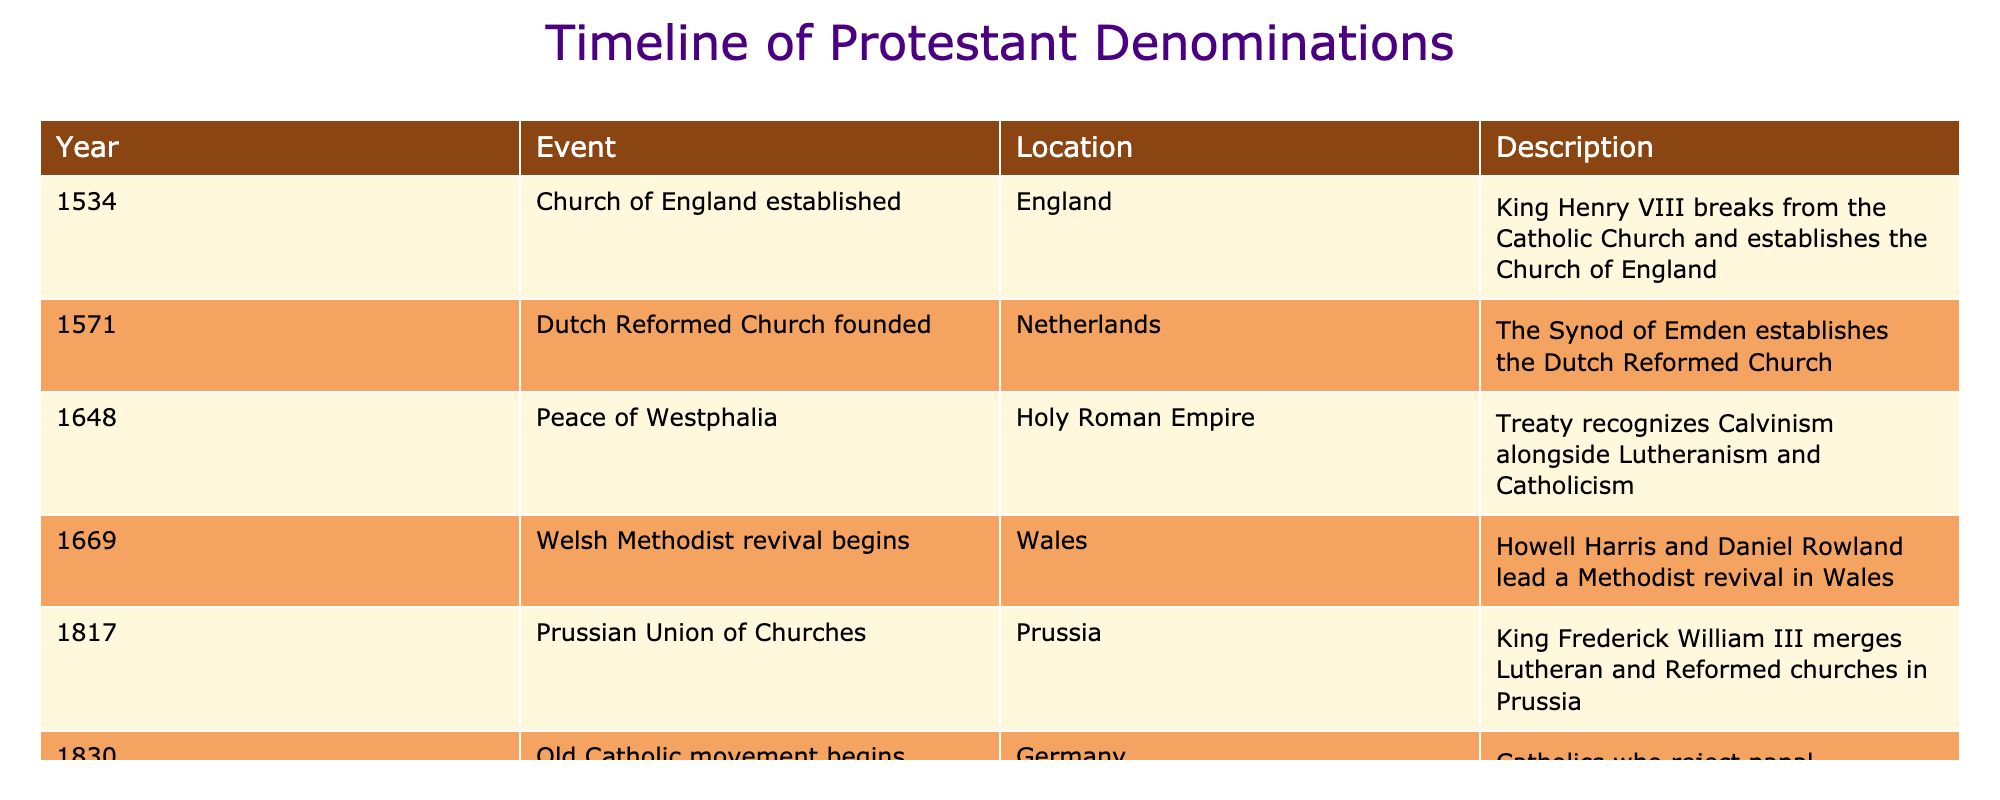What year was the Church of England established? The table shows that the Church of England was established in the year 1534.
Answer: 1534 Which event occurred in the Netherlands in 1571? According to the table, in 1571, the Dutch Reformed Church was founded, established by the Synod of Emden.
Answer: Dutch Reformed Church founded Was the Peace of Westphalia signed before or after the establishment of the Church of England? The Church of England was established in 1534, while the Peace of Westphalia was signed in 1648, making it occur after.
Answer: After How many total events are listed for the 17th century? The events listed in the table between 1600 and 1699 include the Peace of Westphalia in 1648 and the Welsh Methodist revival beginning in 1669, totaling 2 events.
Answer: 2 Which event recognizes Calvinism, Lutheranism, and Catholicism? The Peace of Westphalia, signed in 1648, is the event that recognizes Calvinism alongside Lutheranism and Catholicism.
Answer: Peace of Westphalia What is the difference in years between the founding of the Dutch Reformed Church and the Prussian Union of Churches? The Dutch Reformed Church was founded in 1571 and the Prussian Union of Churches was established in 1817. The difference is 1817 - 1571 = 746 years.
Answer: 746 years Did the Old Catholic movement begin in Germany? The table indicates that the Old Catholic movement began in Germany, confirming that it is true.
Answer: Yes What was the last event listed in the table? The last event in the table is the Old Catholic movement beginning in 1830.
Answer: Old Catholic movement begins Which regions had significant Protestant developments in the 17th century according to the table? The 17th century events listed in the table include the Netherlands (Dutch Reformed Church) and the Holy Roman Empire (Peace of Westphalia), indicating significant developments in these regions.
Answer: Netherlands and Holy Roman Empire 